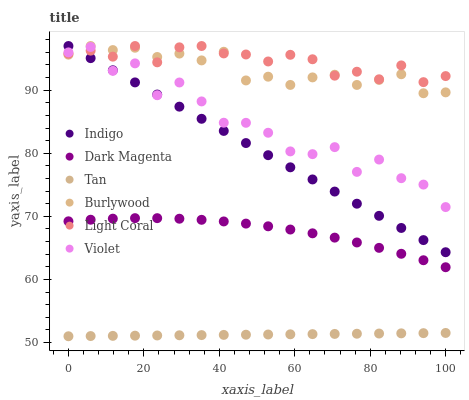Does Tan have the minimum area under the curve?
Answer yes or no. Yes. Does Light Coral have the maximum area under the curve?
Answer yes or no. Yes. Does Dark Magenta have the minimum area under the curve?
Answer yes or no. No. Does Dark Magenta have the maximum area under the curve?
Answer yes or no. No. Is Tan the smoothest?
Answer yes or no. Yes. Is Violet the roughest?
Answer yes or no. Yes. Is Dark Magenta the smoothest?
Answer yes or no. No. Is Dark Magenta the roughest?
Answer yes or no. No. Does Tan have the lowest value?
Answer yes or no. Yes. Does Dark Magenta have the lowest value?
Answer yes or no. No. Does Light Coral have the highest value?
Answer yes or no. Yes. Does Dark Magenta have the highest value?
Answer yes or no. No. Is Dark Magenta less than Indigo?
Answer yes or no. Yes. Is Light Coral greater than Dark Magenta?
Answer yes or no. Yes. Does Light Coral intersect Indigo?
Answer yes or no. Yes. Is Light Coral less than Indigo?
Answer yes or no. No. Is Light Coral greater than Indigo?
Answer yes or no. No. Does Dark Magenta intersect Indigo?
Answer yes or no. No. 